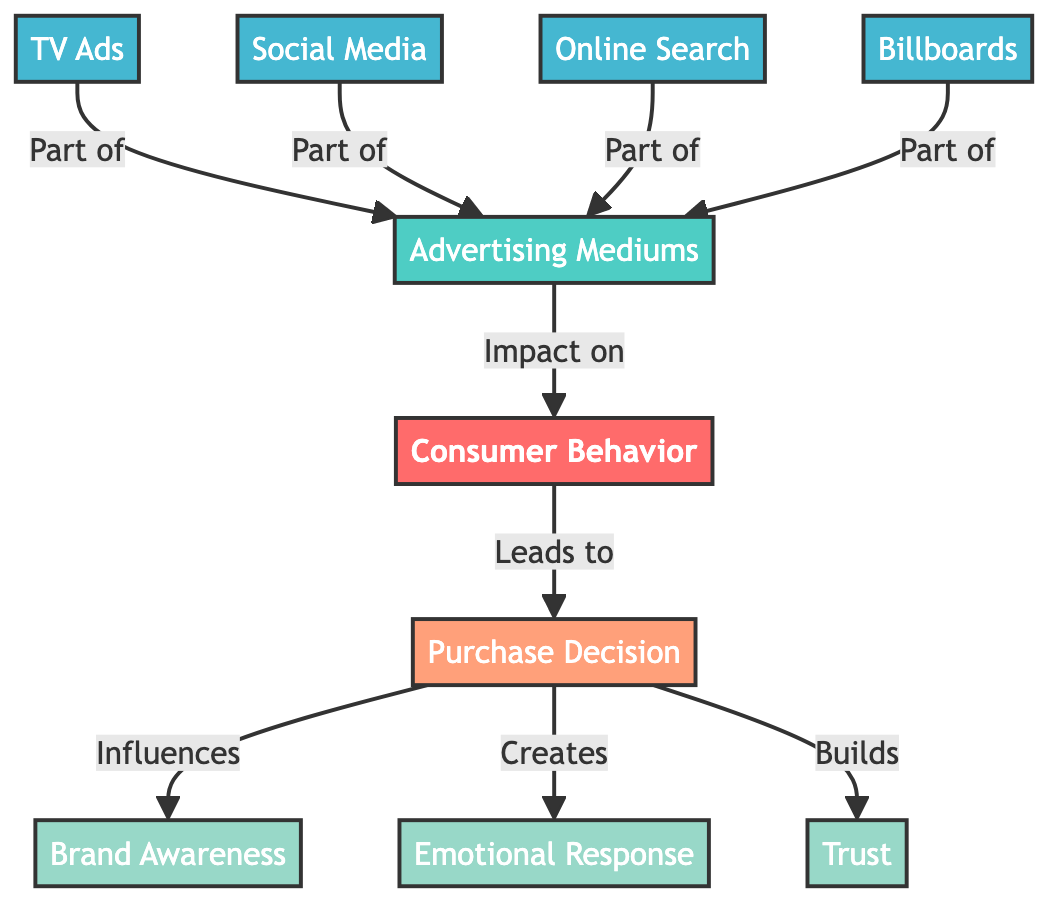What are the four advertising mediums listed in the diagram? The diagram shows four distinct advertising mediums, which are TV Ads, Social Media, Online Search, and Billboards. I can identify them directly from the "Advertising Mediums" section connected to "Consumer Behavior."
Answer: TV Ads, Social Media, Online Search, Billboards How many factors influence the purchase decision according to the diagram? The diagram indicates three factors that influence the purchase decision, which are Brand Awareness, Emotional Response, and Trust. I can count these factors connected to the "Purchase Decision" node.
Answer: 3 What is the relationship between advertising mediums and consumer behavior? The diagram demonstrates that advertising mediums have an impact on consumer behavior. It flows from "Advertising Mediums" to "Consumer Behavior," indicating a direct influence.
Answer: Impact on Which advertising medium does not directly affect the purchase decision? In the diagram, all four advertising mediums (TV Ads, Social Media, Online Search, Billboards) are part of the collective influence on consumer behavior that leads to the purchase decision. Since they all contribute collectively, none can be identified as not affecting it directly. Therefore, the answer is there is none.
Answer: None Which node leads to emotional response creation? According to the diagram, the "Purchase Decision" node creates an emotional response. I see a direct connection from "Purchase Decision" to "Emotional Response," establishing this causal relationship.
Answer: Purchase Decision What factors are influenced by the purchase decision according to the diagram? The diagram lists three outcomes influenced by the purchase decision: Brand Awareness, Emotional Response, and Trust. I identify these factors branching from the "Purchase Decision" node.
Answer: Brand Awareness, Emotional Response, Trust Describe the flow from advertising mediums to purchase decision. The diagram indicates that advertising mediums influence consumer behavior, which subsequently leads to the purchase decision. The flow starts from "Advertising Mediums" affecting "Consumer Behavior," and then this behavior progresses to "Purchase Decision."
Answer: Advertising mediums → Consumer behavior → Purchase decision Which advertising medium has the strongest impact based on the diagram's structure? The diagram does not specify the level of impact from each advertising medium on consumer behavior. Thus, I cannot determine a specific advertising medium with the strongest impact based solely on the provided information.
Answer: Not specified What is the primary central concept of this diagram? The primary central concept illustrated in the diagram is "Consumer Behavior," which is emphasized as the main focus of the flowchart. It is positioned at the center, clearly identifiable among other elements.
Answer: Consumer Behavior 